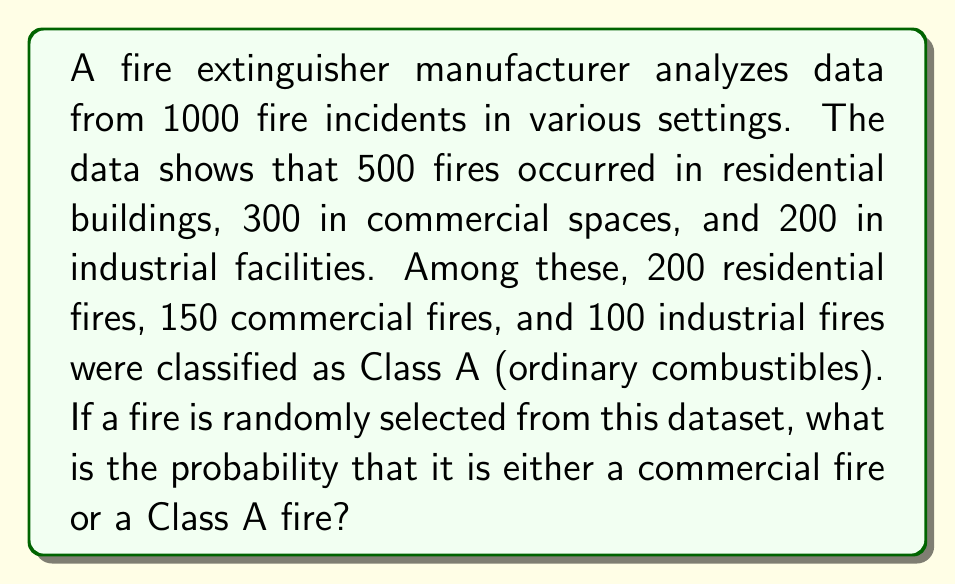Could you help me with this problem? Let's approach this step-by-step:

1) First, let's define our events:
   C: Commercial fire
   A: Class A fire

2) We need to find P(C ∪ A), which is the probability of the fire being either commercial or Class A.

3) We can use the addition rule of probability:
   P(C ∪ A) = P(C) + P(A) - P(C ∩ A)

4) Let's calculate each component:

   P(C) = Number of commercial fires / Total fires
   P(C) = 300 / 1000 = 0.3

   P(A) = Number of Class A fires / Total fires
   P(A) = (200 + 150 + 100) / 1000 = 450 / 1000 = 0.45

   P(C ∩ A) = Number of commercial Class A fires / Total fires
   P(C ∩ A) = 150 / 1000 = 0.15

5) Now we can substitute these values into our formula:

   P(C ∪ A) = 0.3 + 0.45 - 0.15 = 0.6

6) Therefore, the probability is 0.6 or 60%.
Answer: 0.6 